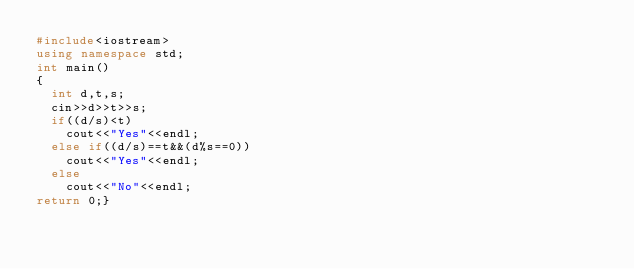Convert code to text. <code><loc_0><loc_0><loc_500><loc_500><_C++_>#include<iostream>
using namespace std;
int main()
{
  int d,t,s;
  cin>>d>>t>>s;
  if((d/s)<t)
    cout<<"Yes"<<endl;
  else if((d/s)==t&&(d%s==0))
    cout<<"Yes"<<endl;
  else
    cout<<"No"<<endl;
return 0;}
</code> 